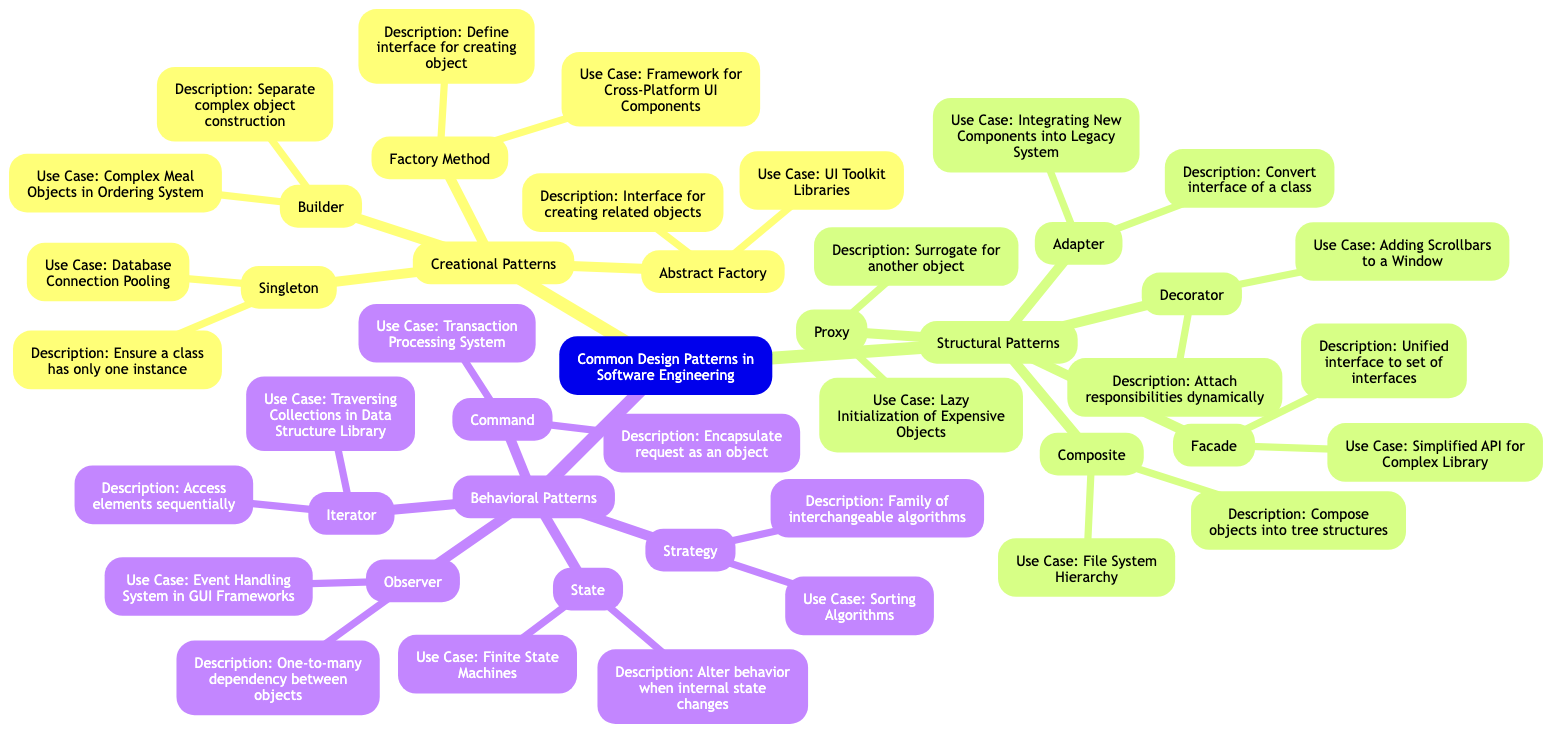What is the use case for the Singleton pattern? The Singleton pattern's use case is provided in the diagram as "Database Connection Pooling." This means that the Singleton pattern ensures there is a single instance of the database connection that can be accessed globally.
Answer: Database Connection Pooling How many Structural Patterns are there in the diagram? By counting the listed patterns under the "Structural Patterns" section in the diagram, there are five patterns: Adapter, Composite, Decorator, Facade, and Proxy. Thus, the total is five.
Answer: 5 What is the description of the Factory Method pattern? The description of the Factory Method pattern states that it defines an interface for creating an object, allowing subclasses to alter the type of objects created. This is found directly under the Factory Method node in the diagram.
Answer: Define an interface for creating object What is a use case for the Decorator pattern? The use case for the Decorator pattern is given as "Adding Scrollbars to a Window," indicating how the pattern can be applied to enhance functionalities dynamically by attaching additional responsibilities.
Answer: Adding Scrollbars to a Window Which pattern allows an object to alter its behavior when its internal state changes? This is described under the State pattern in the diagram, which specifies that it enables an object to change its behavior based on its current internal state. To answer the question, we refer specifically to the State pattern.
Answer: State 